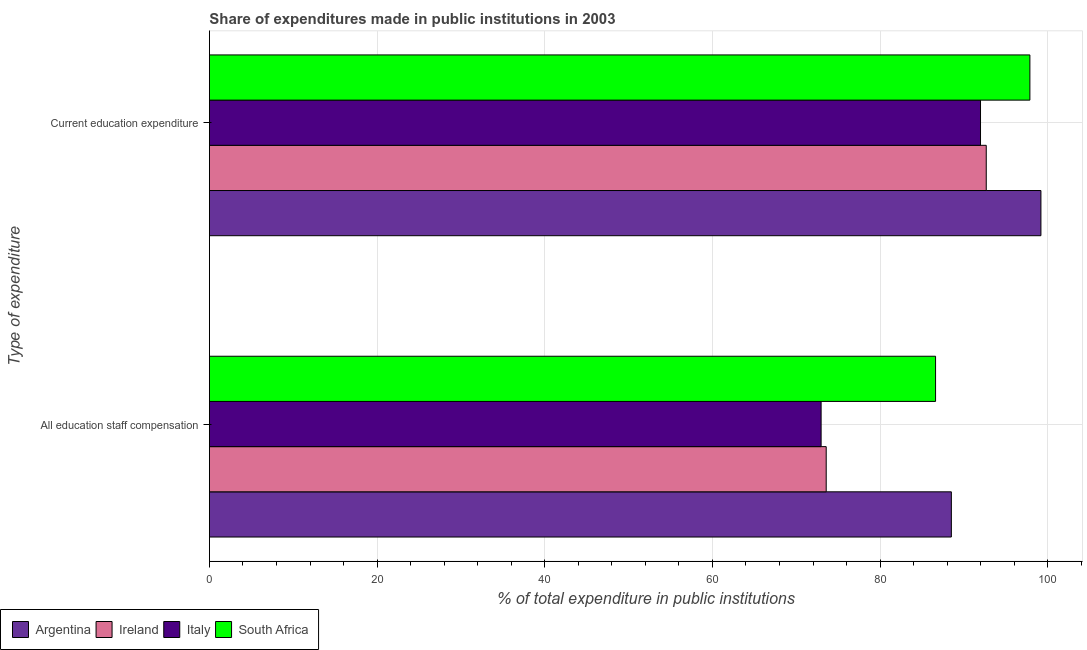How many different coloured bars are there?
Make the answer very short. 4. Are the number of bars per tick equal to the number of legend labels?
Give a very brief answer. Yes. How many bars are there on the 2nd tick from the top?
Keep it short and to the point. 4. How many bars are there on the 2nd tick from the bottom?
Offer a terse response. 4. What is the label of the 1st group of bars from the top?
Offer a terse response. Current education expenditure. What is the expenditure in education in South Africa?
Your answer should be compact. 97.87. Across all countries, what is the maximum expenditure in education?
Your answer should be compact. 99.19. Across all countries, what is the minimum expenditure in staff compensation?
Provide a succinct answer. 72.97. What is the total expenditure in staff compensation in the graph?
Keep it short and to the point. 321.67. What is the difference between the expenditure in staff compensation in South Africa and that in Argentina?
Provide a succinct answer. -1.88. What is the difference between the expenditure in staff compensation in Ireland and the expenditure in education in South Africa?
Your answer should be compact. -24.3. What is the average expenditure in education per country?
Ensure brevity in your answer.  95.43. What is the difference between the expenditure in staff compensation and expenditure in education in Ireland?
Provide a short and direct response. -19.09. In how many countries, is the expenditure in staff compensation greater than 68 %?
Your answer should be compact. 4. What is the ratio of the expenditure in staff compensation in South Africa to that in Italy?
Keep it short and to the point. 1.19. Is the expenditure in education in Italy less than that in Argentina?
Keep it short and to the point. Yes. What does the 3rd bar from the bottom in Current education expenditure represents?
Provide a succinct answer. Italy. Does the graph contain any zero values?
Provide a short and direct response. No. Does the graph contain grids?
Offer a very short reply. Yes. How many legend labels are there?
Your answer should be compact. 4. What is the title of the graph?
Ensure brevity in your answer.  Share of expenditures made in public institutions in 2003. Does "St. Vincent and the Grenadines" appear as one of the legend labels in the graph?
Provide a succinct answer. No. What is the label or title of the X-axis?
Ensure brevity in your answer.  % of total expenditure in public institutions. What is the label or title of the Y-axis?
Offer a terse response. Type of expenditure. What is the % of total expenditure in public institutions of Argentina in All education staff compensation?
Your answer should be very brief. 88.51. What is the % of total expenditure in public institutions of Ireland in All education staff compensation?
Provide a short and direct response. 73.58. What is the % of total expenditure in public institutions in Italy in All education staff compensation?
Make the answer very short. 72.97. What is the % of total expenditure in public institutions of South Africa in All education staff compensation?
Provide a succinct answer. 86.62. What is the % of total expenditure in public institutions in Argentina in Current education expenditure?
Make the answer very short. 99.19. What is the % of total expenditure in public institutions in Ireland in Current education expenditure?
Ensure brevity in your answer.  92.67. What is the % of total expenditure in public institutions of Italy in Current education expenditure?
Offer a very short reply. 91.98. What is the % of total expenditure in public institutions of South Africa in Current education expenditure?
Offer a terse response. 97.87. Across all Type of expenditure, what is the maximum % of total expenditure in public institutions of Argentina?
Provide a succinct answer. 99.19. Across all Type of expenditure, what is the maximum % of total expenditure in public institutions of Ireland?
Make the answer very short. 92.67. Across all Type of expenditure, what is the maximum % of total expenditure in public institutions of Italy?
Provide a short and direct response. 91.98. Across all Type of expenditure, what is the maximum % of total expenditure in public institutions of South Africa?
Offer a terse response. 97.87. Across all Type of expenditure, what is the minimum % of total expenditure in public institutions in Argentina?
Your answer should be compact. 88.51. Across all Type of expenditure, what is the minimum % of total expenditure in public institutions in Ireland?
Ensure brevity in your answer.  73.58. Across all Type of expenditure, what is the minimum % of total expenditure in public institutions of Italy?
Your response must be concise. 72.97. Across all Type of expenditure, what is the minimum % of total expenditure in public institutions in South Africa?
Your answer should be very brief. 86.62. What is the total % of total expenditure in public institutions in Argentina in the graph?
Your response must be concise. 187.69. What is the total % of total expenditure in public institutions in Ireland in the graph?
Provide a short and direct response. 166.24. What is the total % of total expenditure in public institutions in Italy in the graph?
Your response must be concise. 164.95. What is the total % of total expenditure in public institutions in South Africa in the graph?
Your response must be concise. 184.49. What is the difference between the % of total expenditure in public institutions in Argentina in All education staff compensation and that in Current education expenditure?
Make the answer very short. -10.68. What is the difference between the % of total expenditure in public institutions in Ireland in All education staff compensation and that in Current education expenditure?
Your answer should be very brief. -19.09. What is the difference between the % of total expenditure in public institutions in Italy in All education staff compensation and that in Current education expenditure?
Offer a terse response. -19.02. What is the difference between the % of total expenditure in public institutions of South Africa in All education staff compensation and that in Current education expenditure?
Your answer should be compact. -11.25. What is the difference between the % of total expenditure in public institutions of Argentina in All education staff compensation and the % of total expenditure in public institutions of Ireland in Current education expenditure?
Your answer should be very brief. -4.16. What is the difference between the % of total expenditure in public institutions of Argentina in All education staff compensation and the % of total expenditure in public institutions of Italy in Current education expenditure?
Your answer should be compact. -3.48. What is the difference between the % of total expenditure in public institutions of Argentina in All education staff compensation and the % of total expenditure in public institutions of South Africa in Current education expenditure?
Keep it short and to the point. -9.37. What is the difference between the % of total expenditure in public institutions in Ireland in All education staff compensation and the % of total expenditure in public institutions in Italy in Current education expenditure?
Keep it short and to the point. -18.41. What is the difference between the % of total expenditure in public institutions in Ireland in All education staff compensation and the % of total expenditure in public institutions in South Africa in Current education expenditure?
Provide a succinct answer. -24.3. What is the difference between the % of total expenditure in public institutions in Italy in All education staff compensation and the % of total expenditure in public institutions in South Africa in Current education expenditure?
Offer a terse response. -24.9. What is the average % of total expenditure in public institutions of Argentina per Type of expenditure?
Ensure brevity in your answer.  93.85. What is the average % of total expenditure in public institutions in Ireland per Type of expenditure?
Ensure brevity in your answer.  83.12. What is the average % of total expenditure in public institutions of Italy per Type of expenditure?
Your answer should be very brief. 82.48. What is the average % of total expenditure in public institutions of South Africa per Type of expenditure?
Offer a very short reply. 92.25. What is the difference between the % of total expenditure in public institutions of Argentina and % of total expenditure in public institutions of Ireland in All education staff compensation?
Provide a succinct answer. 14.93. What is the difference between the % of total expenditure in public institutions of Argentina and % of total expenditure in public institutions of Italy in All education staff compensation?
Make the answer very short. 15.54. What is the difference between the % of total expenditure in public institutions of Argentina and % of total expenditure in public institutions of South Africa in All education staff compensation?
Your response must be concise. 1.88. What is the difference between the % of total expenditure in public institutions of Ireland and % of total expenditure in public institutions of Italy in All education staff compensation?
Your answer should be very brief. 0.61. What is the difference between the % of total expenditure in public institutions of Ireland and % of total expenditure in public institutions of South Africa in All education staff compensation?
Keep it short and to the point. -13.05. What is the difference between the % of total expenditure in public institutions in Italy and % of total expenditure in public institutions in South Africa in All education staff compensation?
Offer a terse response. -13.65. What is the difference between the % of total expenditure in public institutions in Argentina and % of total expenditure in public institutions in Ireland in Current education expenditure?
Your answer should be compact. 6.52. What is the difference between the % of total expenditure in public institutions of Argentina and % of total expenditure in public institutions of Italy in Current education expenditure?
Your answer should be compact. 7.2. What is the difference between the % of total expenditure in public institutions of Argentina and % of total expenditure in public institutions of South Africa in Current education expenditure?
Ensure brevity in your answer.  1.32. What is the difference between the % of total expenditure in public institutions of Ireland and % of total expenditure in public institutions of Italy in Current education expenditure?
Provide a short and direct response. 0.68. What is the difference between the % of total expenditure in public institutions in Ireland and % of total expenditure in public institutions in South Africa in Current education expenditure?
Provide a short and direct response. -5.21. What is the difference between the % of total expenditure in public institutions in Italy and % of total expenditure in public institutions in South Africa in Current education expenditure?
Your answer should be very brief. -5.89. What is the ratio of the % of total expenditure in public institutions of Argentina in All education staff compensation to that in Current education expenditure?
Offer a very short reply. 0.89. What is the ratio of the % of total expenditure in public institutions of Ireland in All education staff compensation to that in Current education expenditure?
Offer a very short reply. 0.79. What is the ratio of the % of total expenditure in public institutions in Italy in All education staff compensation to that in Current education expenditure?
Offer a very short reply. 0.79. What is the ratio of the % of total expenditure in public institutions of South Africa in All education staff compensation to that in Current education expenditure?
Make the answer very short. 0.89. What is the difference between the highest and the second highest % of total expenditure in public institutions of Argentina?
Your answer should be compact. 10.68. What is the difference between the highest and the second highest % of total expenditure in public institutions of Ireland?
Offer a terse response. 19.09. What is the difference between the highest and the second highest % of total expenditure in public institutions of Italy?
Offer a terse response. 19.02. What is the difference between the highest and the second highest % of total expenditure in public institutions in South Africa?
Give a very brief answer. 11.25. What is the difference between the highest and the lowest % of total expenditure in public institutions in Argentina?
Your response must be concise. 10.68. What is the difference between the highest and the lowest % of total expenditure in public institutions in Ireland?
Keep it short and to the point. 19.09. What is the difference between the highest and the lowest % of total expenditure in public institutions of Italy?
Offer a terse response. 19.02. What is the difference between the highest and the lowest % of total expenditure in public institutions in South Africa?
Give a very brief answer. 11.25. 